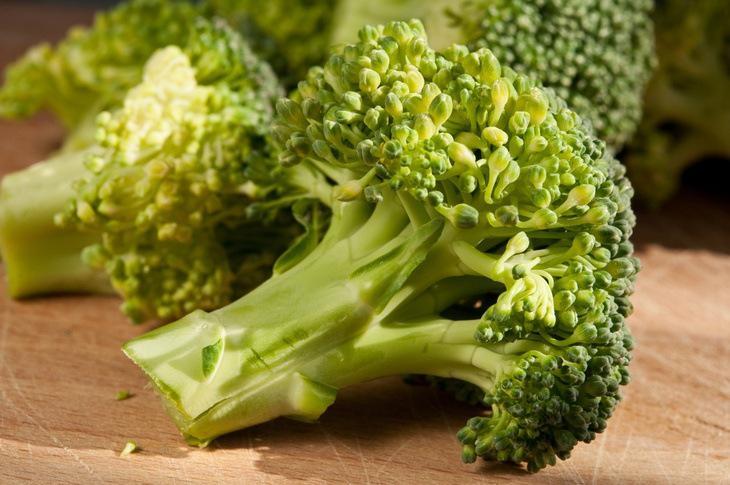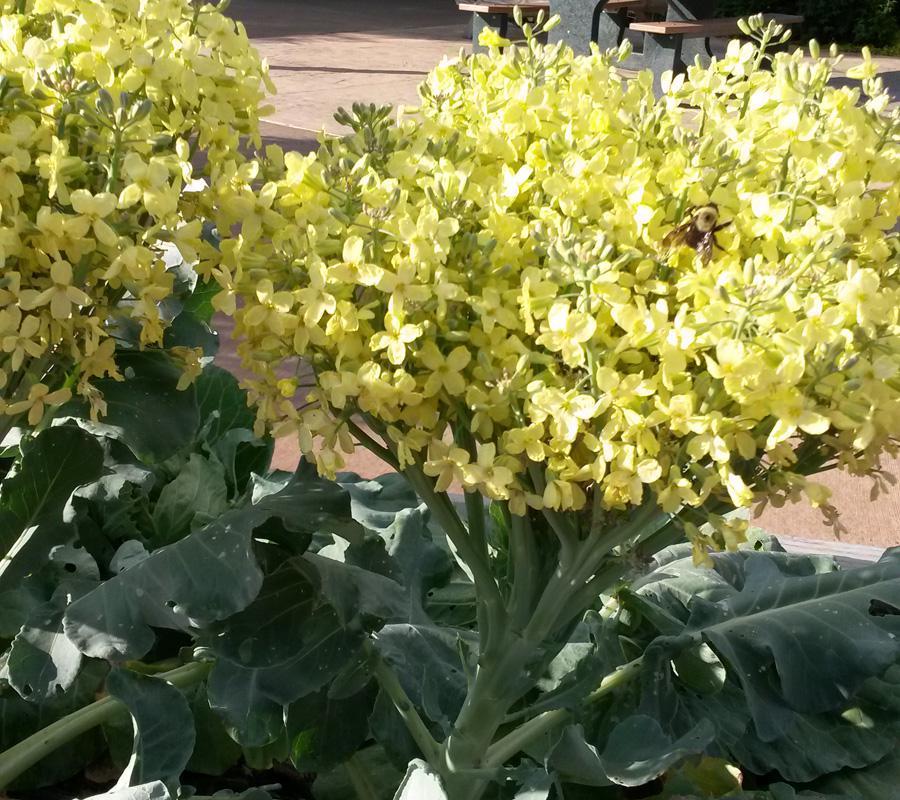The first image is the image on the left, the second image is the image on the right. For the images shown, is this caption "The left and right image contains the same number of romanesco broccoli." true? Answer yes or no. No. 